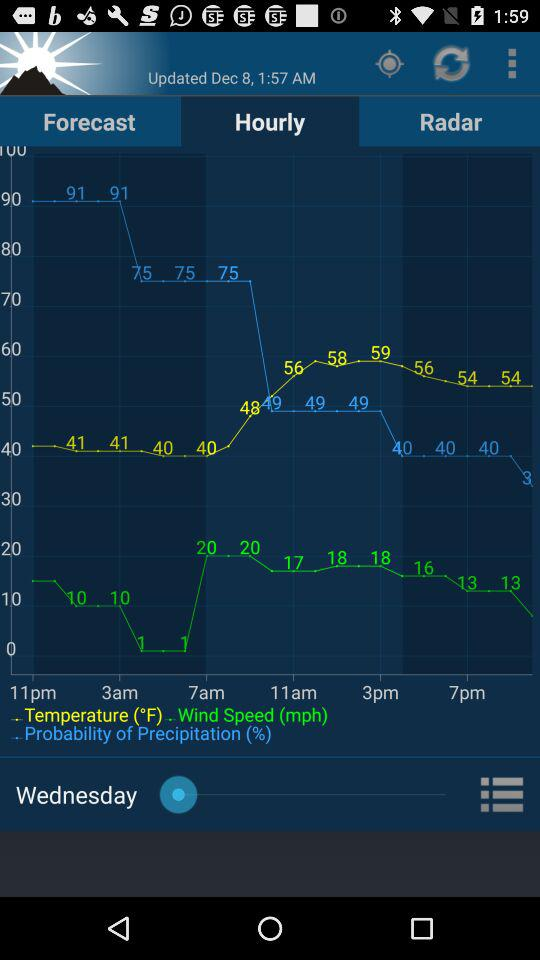Which tab is selected? The selected tab is "Hourly". 